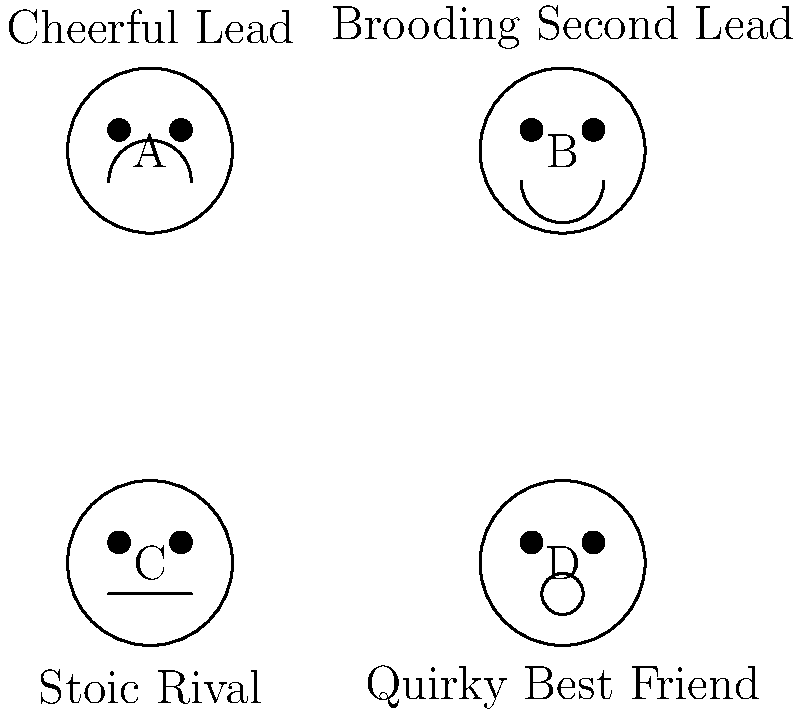In the diagram above, which facial expression would most likely represent the "Tsundere" character archetype often seen in K-dramas? To answer this question, let's analyze each facial expression and consider the characteristics of a "Tsundere" character:

1. Face A (Cheerful Lead): Shows a happy, upbeat expression with a big smile. This doesn't match the typical Tsundere personality.

2. Face B (Brooding Second Lead): Displays a frowning expression, indicating a more serious or upset mood. This could potentially represent a Tsundere in their "cold" phase.

3. Face C (Stoic Rival): Shows a neutral expression with a straight line for a mouth. This represents a character who doesn't show much emotion, which isn't typical for a Tsundere.

4. Face D (Quirky Best Friend): Has a slightly more complex mouth shape, potentially indicating a mix of emotions or a quirky personality.

A "Tsundere" character is typically defined by their hot and cold personality, often starting off cold or hostile before gradually showing their warmer, caring side. They tend to have difficulty expressing their true feelings.

Given these characteristics, the facial expression that best represents a Tsundere would be Face B (Brooding Second Lead). The frowning expression could represent the initial cold or hostile facade that a Tsundere often presents, hiding their true feelings behind a tough exterior.

While a Tsundere might occasionally show other expressions, the brooding look is most representative of their typical outward appearance, especially in their initial interactions or when trying to mask their true emotions.
Answer: B (Brooding Second Lead) 